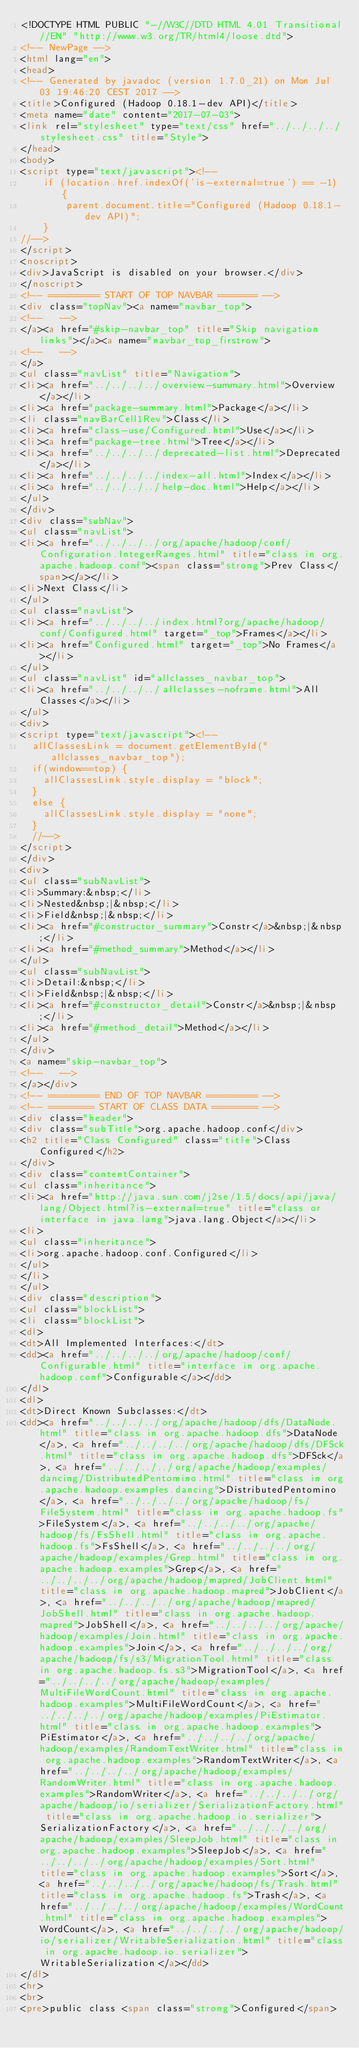Convert code to text. <code><loc_0><loc_0><loc_500><loc_500><_HTML_><!DOCTYPE HTML PUBLIC "-//W3C//DTD HTML 4.01 Transitional//EN" "http://www.w3.org/TR/html4/loose.dtd">
<!-- NewPage -->
<html lang="en">
<head>
<!-- Generated by javadoc (version 1.7.0_21) on Mon Jul 03 19:46:20 CEST 2017 -->
<title>Configured (Hadoop 0.18.1-dev API)</title>
<meta name="date" content="2017-07-03">
<link rel="stylesheet" type="text/css" href="../../../../stylesheet.css" title="Style">
</head>
<body>
<script type="text/javascript"><!--
    if (location.href.indexOf('is-external=true') == -1) {
        parent.document.title="Configured (Hadoop 0.18.1-dev API)";
    }
//-->
</script>
<noscript>
<div>JavaScript is disabled on your browser.</div>
</noscript>
<!-- ========= START OF TOP NAVBAR ======= -->
<div class="topNav"><a name="navbar_top">
<!--   -->
</a><a href="#skip-navbar_top" title="Skip navigation links"></a><a name="navbar_top_firstrow">
<!--   -->
</a>
<ul class="navList" title="Navigation">
<li><a href="../../../../overview-summary.html">Overview</a></li>
<li><a href="package-summary.html">Package</a></li>
<li class="navBarCell1Rev">Class</li>
<li><a href="class-use/Configured.html">Use</a></li>
<li><a href="package-tree.html">Tree</a></li>
<li><a href="../../../../deprecated-list.html">Deprecated</a></li>
<li><a href="../../../../index-all.html">Index</a></li>
<li><a href="../../../../help-doc.html">Help</a></li>
</ul>
</div>
<div class="subNav">
<ul class="navList">
<li><a href="../../../../org/apache/hadoop/conf/Configuration.IntegerRanges.html" title="class in org.apache.hadoop.conf"><span class="strong">Prev Class</span></a></li>
<li>Next Class</li>
</ul>
<ul class="navList">
<li><a href="../../../../index.html?org/apache/hadoop/conf/Configured.html" target="_top">Frames</a></li>
<li><a href="Configured.html" target="_top">No Frames</a></li>
</ul>
<ul class="navList" id="allclasses_navbar_top">
<li><a href="../../../../allclasses-noframe.html">All Classes</a></li>
</ul>
<div>
<script type="text/javascript"><!--
  allClassesLink = document.getElementById("allclasses_navbar_top");
  if(window==top) {
    allClassesLink.style.display = "block";
  }
  else {
    allClassesLink.style.display = "none";
  }
  //-->
</script>
</div>
<div>
<ul class="subNavList">
<li>Summary:&nbsp;</li>
<li>Nested&nbsp;|&nbsp;</li>
<li>Field&nbsp;|&nbsp;</li>
<li><a href="#constructor_summary">Constr</a>&nbsp;|&nbsp;</li>
<li><a href="#method_summary">Method</a></li>
</ul>
<ul class="subNavList">
<li>Detail:&nbsp;</li>
<li>Field&nbsp;|&nbsp;</li>
<li><a href="#constructor_detail">Constr</a>&nbsp;|&nbsp;</li>
<li><a href="#method_detail">Method</a></li>
</ul>
</div>
<a name="skip-navbar_top">
<!--   -->
</a></div>
<!-- ========= END OF TOP NAVBAR ========= -->
<!-- ======== START OF CLASS DATA ======== -->
<div class="header">
<div class="subTitle">org.apache.hadoop.conf</div>
<h2 title="Class Configured" class="title">Class Configured</h2>
</div>
<div class="contentContainer">
<ul class="inheritance">
<li><a href="http://java.sun.com/j2se/1.5/docs/api/java/lang/Object.html?is-external=true" title="class or interface in java.lang">java.lang.Object</a></li>
<li>
<ul class="inheritance">
<li>org.apache.hadoop.conf.Configured</li>
</ul>
</li>
</ul>
<div class="description">
<ul class="blockList">
<li class="blockList">
<dl>
<dt>All Implemented Interfaces:</dt>
<dd><a href="../../../../org/apache/hadoop/conf/Configurable.html" title="interface in org.apache.hadoop.conf">Configurable</a></dd>
</dl>
<dl>
<dt>Direct Known Subclasses:</dt>
<dd><a href="../../../../org/apache/hadoop/dfs/DataNode.html" title="class in org.apache.hadoop.dfs">DataNode</a>, <a href="../../../../org/apache/hadoop/dfs/DFSck.html" title="class in org.apache.hadoop.dfs">DFSck</a>, <a href="../../../../org/apache/hadoop/examples/dancing/DistributedPentomino.html" title="class in org.apache.hadoop.examples.dancing">DistributedPentomino</a>, <a href="../../../../org/apache/hadoop/fs/FileSystem.html" title="class in org.apache.hadoop.fs">FileSystem</a>, <a href="../../../../org/apache/hadoop/fs/FsShell.html" title="class in org.apache.hadoop.fs">FsShell</a>, <a href="../../../../org/apache/hadoop/examples/Grep.html" title="class in org.apache.hadoop.examples">Grep</a>, <a href="../../../../org/apache/hadoop/mapred/JobClient.html" title="class in org.apache.hadoop.mapred">JobClient</a>, <a href="../../../../org/apache/hadoop/mapred/JobShell.html" title="class in org.apache.hadoop.mapred">JobShell</a>, <a href="../../../../org/apache/hadoop/examples/Join.html" title="class in org.apache.hadoop.examples">Join</a>, <a href="../../../../org/apache/hadoop/fs/s3/MigrationTool.html" title="class in org.apache.hadoop.fs.s3">MigrationTool</a>, <a href="../../../../org/apache/hadoop/examples/MultiFileWordCount.html" title="class in org.apache.hadoop.examples">MultiFileWordCount</a>, <a href="../../../../org/apache/hadoop/examples/PiEstimator.html" title="class in org.apache.hadoop.examples">PiEstimator</a>, <a href="../../../../org/apache/hadoop/examples/RandomTextWriter.html" title="class in org.apache.hadoop.examples">RandomTextWriter</a>, <a href="../../../../org/apache/hadoop/examples/RandomWriter.html" title="class in org.apache.hadoop.examples">RandomWriter</a>, <a href="../../../../org/apache/hadoop/io/serializer/SerializationFactory.html" title="class in org.apache.hadoop.io.serializer">SerializationFactory</a>, <a href="../../../../org/apache/hadoop/examples/SleepJob.html" title="class in org.apache.hadoop.examples">SleepJob</a>, <a href="../../../../org/apache/hadoop/examples/Sort.html" title="class in org.apache.hadoop.examples">Sort</a>, <a href="../../../../org/apache/hadoop/fs/Trash.html" title="class in org.apache.hadoop.fs">Trash</a>, <a href="../../../../org/apache/hadoop/examples/WordCount.html" title="class in org.apache.hadoop.examples">WordCount</a>, <a href="../../../../org/apache/hadoop/io/serializer/WritableSerialization.html" title="class in org.apache.hadoop.io.serializer">WritableSerialization</a></dd>
</dl>
<hr>
<br>
<pre>public class <span class="strong">Configured</span></code> 